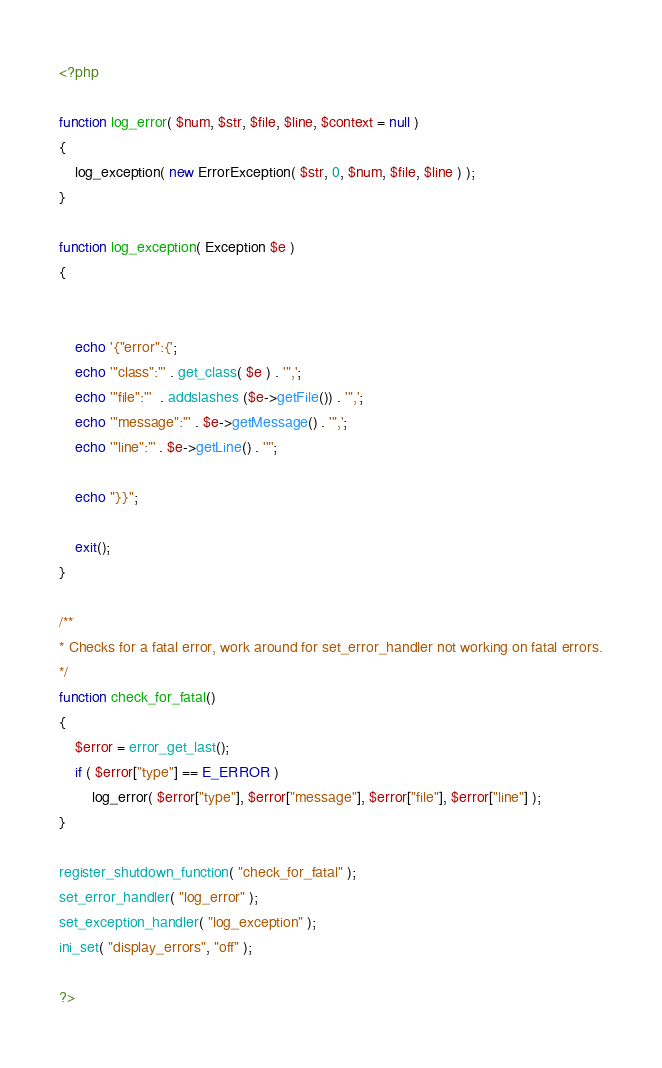<code> <loc_0><loc_0><loc_500><loc_500><_PHP_><?php

function log_error( $num, $str, $file, $line, $context = null )
{
    log_exception( new ErrorException( $str, 0, $num, $file, $line ) );
}

function log_exception( Exception $e )
{


    echo '{"error":{';
    echo '"class":"' . get_class( $e ) . '",';
    echo '"file":"'  . addslashes ($e->getFile()) . '",';
    echo '"message":"' . $e->getMessage() . '",';
    echo '"line":"' . $e->getLine() . '"';

    echo "}}";

    exit();
}

/**
* Checks for a fatal error, work around for set_error_handler not working on fatal errors.
*/
function check_for_fatal()
{
    $error = error_get_last();
    if ( $error["type"] == E_ERROR )
        log_error( $error["type"], $error["message"], $error["file"], $error["line"] );
}

register_shutdown_function( "check_for_fatal" );
set_error_handler( "log_error" );
set_exception_handler( "log_exception" );
ini_set( "display_errors", "off" );

?></code> 